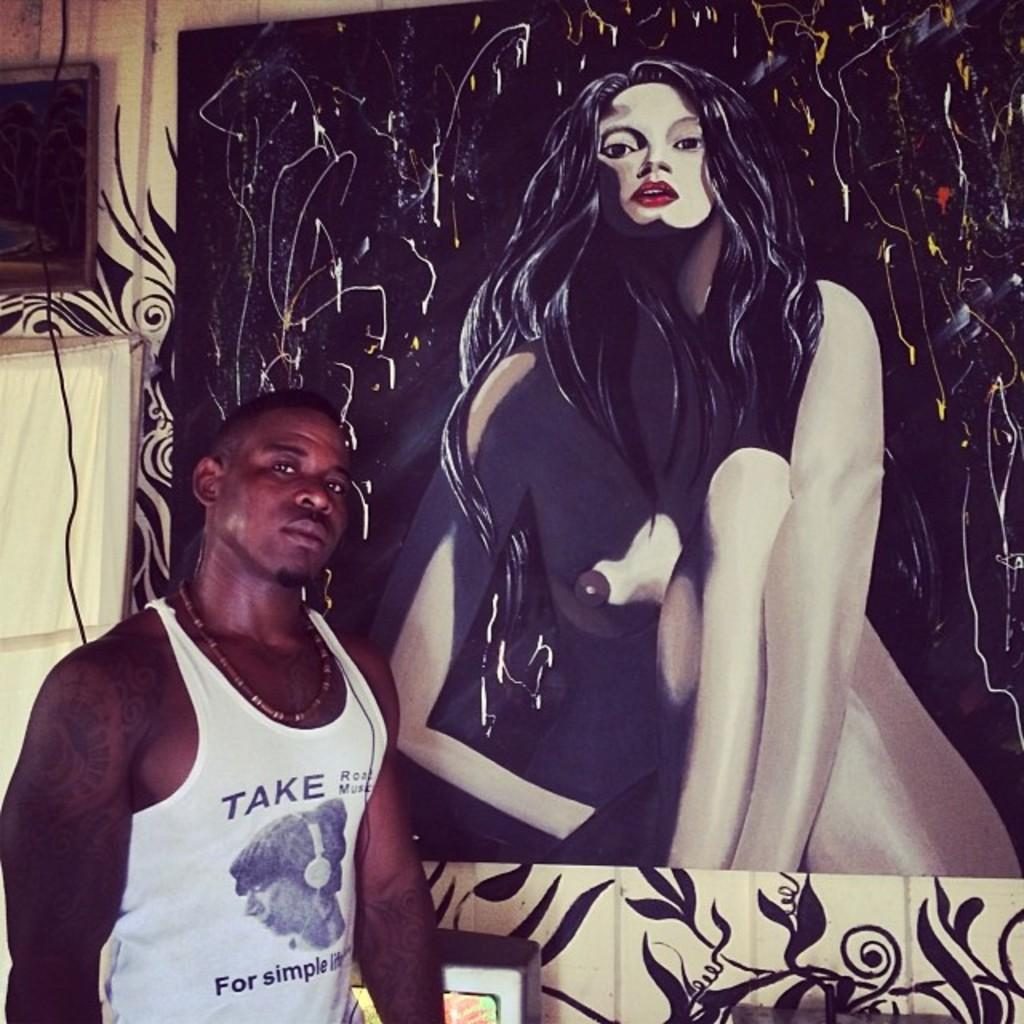<image>
Summarize the visual content of the image. A man wears a tank top with the word take on it. 